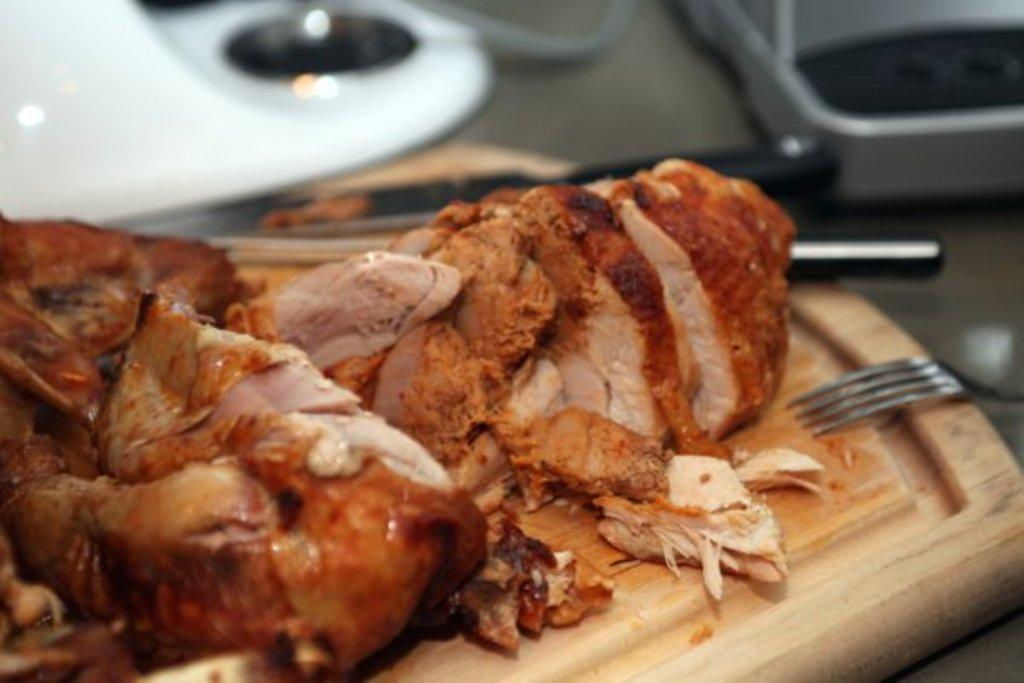What utensils can be seen in the image? There is a fork and a knife in the image. What is on the wooden object in the image? There is meat on a wooden object in the image. Can you describe the background of the image? There are objects visible in the background of the image. What type of book is being offered to the animals on the farm in the image? There is no book or farm present in the image; it features a fork, knife, and meat on a wooden object. 